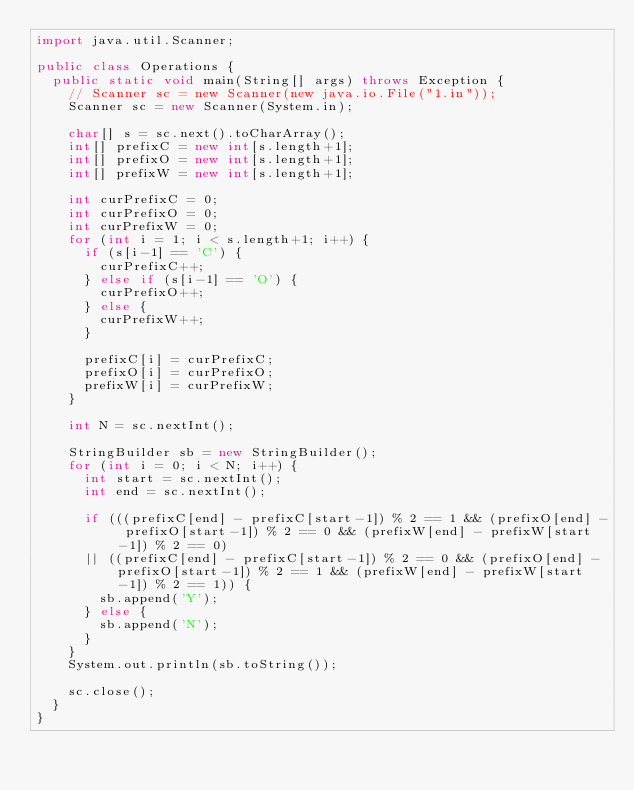<code> <loc_0><loc_0><loc_500><loc_500><_Java_>import java.util.Scanner;

public class Operations {
  public static void main(String[] args) throws Exception {
    // Scanner sc = new Scanner(new java.io.File("1.in"));
    Scanner sc = new Scanner(System.in);

    char[] s = sc.next().toCharArray();
    int[] prefixC = new int[s.length+1];
    int[] prefixO = new int[s.length+1];
    int[] prefixW = new int[s.length+1];

    int curPrefixC = 0;
    int curPrefixO = 0;
    int curPrefixW = 0;
    for (int i = 1; i < s.length+1; i++) {
      if (s[i-1] == 'C') {
        curPrefixC++;
      } else if (s[i-1] == 'O') {
        curPrefixO++;
      } else {
        curPrefixW++;
      }

      prefixC[i] = curPrefixC;
      prefixO[i] = curPrefixO;
      prefixW[i] = curPrefixW;
    }

    int N = sc.nextInt();

    StringBuilder sb = new StringBuilder();
    for (int i = 0; i < N; i++) {
      int start = sc.nextInt();
      int end = sc.nextInt();

      if (((prefixC[end] - prefixC[start-1]) % 2 == 1 && (prefixO[end] - prefixO[start-1]) % 2 == 0 && (prefixW[end] - prefixW[start-1]) % 2 == 0)
      || ((prefixC[end] - prefixC[start-1]) % 2 == 0 && (prefixO[end] - prefixO[start-1]) % 2 == 1 && (prefixW[end] - prefixW[start-1]) % 2 == 1)) {
        sb.append('Y');
      } else {
        sb.append('N');
      }
    }
    System.out.println(sb.toString());

    sc.close();
  }
}</code> 